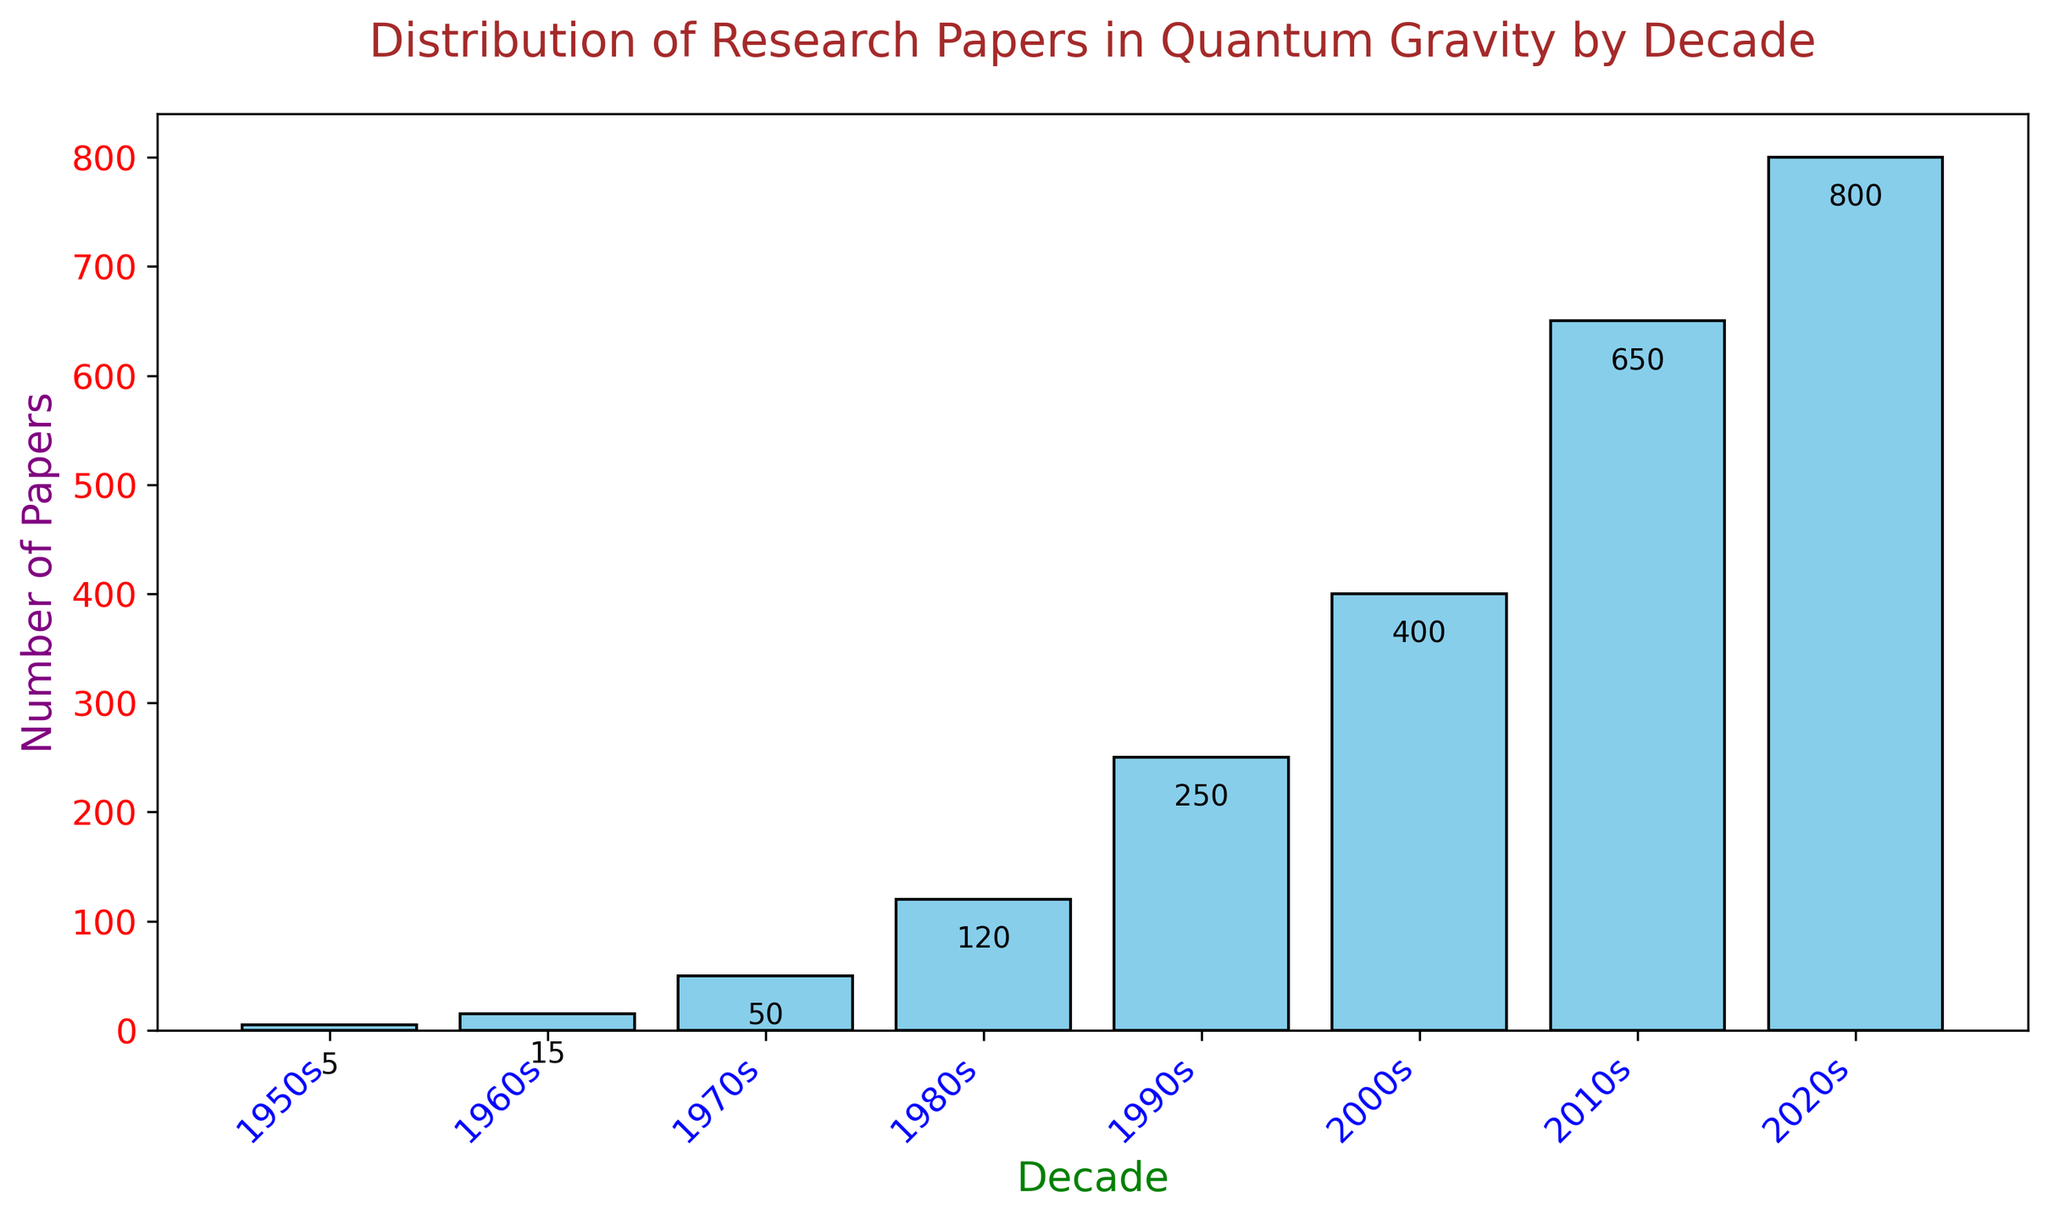Which decade saw the highest number of research papers published in Quantum Gravity? Examine the heights of the bars to identify the tallest one. The bar for the 2020s is the tallest, indicating this decade saw the most publications.
Answer: 2020s Which decades had fewer than 100 research papers published in Quantum Gravity? Identify the bars with heights below 100. The bars for the 1950s, 1960s, and 1970s are below this threshold.
Answer: 1950s, 1960s, 1970s How many more research papers were published in the 2010s compared to the 2000s? Subtract the number of papers in the 2000s (400) from the number in the 2010s (650) to find the difference: 650 - 400 = 250.
Answer: 250 Calculate the total number of research papers published in Quantum Gravity from the 1950s to the 1980s. Sum the number of papers in the 1950s (5), 1960s (15), 1970s (50), and 1980s (120): 5 + 15 + 50 + 120 = 190.
Answer: 190 Which decade saw the largest increase in the number of research papers published compared to the previous decade? Calculate the difference between each consecutive decade: 
1960s - 1950s: 15 - 5 = 10
1970s - 1960s: 50 - 15 = 35
1980s - 1970s: 120 - 50 = 70
1990s - 1980s: 250 - 120 = 130
2000s - 1990s: 400 - 250 = 150
2010s - 2000s: 650 - 400 = 250
2020s - 2010s: 800 - 650 = 150
The largest increase of 250 papers occurred between the 2000s and the 2010s.
Answer: 2010s What is the average number of research papers published per decade from the 1950s to the 2020s? Add the number of papers for all decades and divide by the number of decades:
(5 + 15 + 50 + 120 + 250 + 400 + 650 + 800) / 8 = 2290 / 8 = 286.25.
Answer: 286.25 What is the trend in the number of research papers published in Quantum Gravity from the 1950s to the 2020s? Observe the pattern of increasing bar heights from the 1950s to the 2020s, indicating a steady rise.
Answer: Increasing 